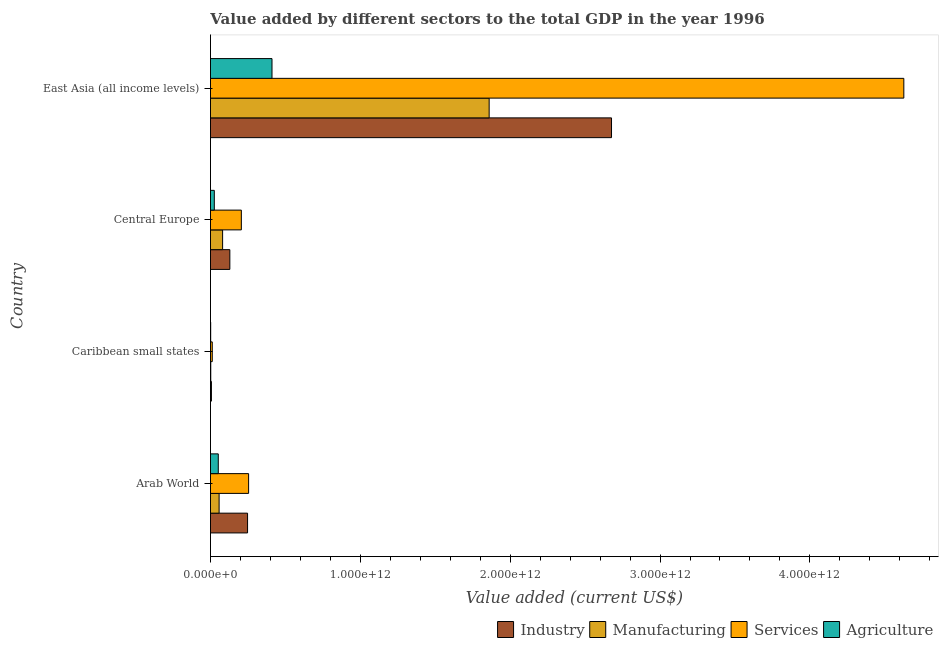How many different coloured bars are there?
Provide a succinct answer. 4. How many groups of bars are there?
Give a very brief answer. 4. Are the number of bars per tick equal to the number of legend labels?
Offer a terse response. Yes. How many bars are there on the 4th tick from the bottom?
Offer a very short reply. 4. What is the label of the 2nd group of bars from the top?
Your response must be concise. Central Europe. In how many cases, is the number of bars for a given country not equal to the number of legend labels?
Provide a succinct answer. 0. What is the value added by agricultural sector in Arab World?
Ensure brevity in your answer.  5.21e+1. Across all countries, what is the maximum value added by manufacturing sector?
Provide a short and direct response. 1.86e+12. Across all countries, what is the minimum value added by industrial sector?
Offer a terse response. 6.28e+09. In which country was the value added by services sector maximum?
Provide a succinct answer. East Asia (all income levels). In which country was the value added by services sector minimum?
Make the answer very short. Caribbean small states. What is the total value added by agricultural sector in the graph?
Ensure brevity in your answer.  4.90e+11. What is the difference between the value added by industrial sector in Arab World and that in East Asia (all income levels)?
Your answer should be very brief. -2.43e+12. What is the difference between the value added by manufacturing sector in Central Europe and the value added by agricultural sector in Caribbean small states?
Provide a succinct answer. 7.96e+1. What is the average value added by services sector per country?
Provide a short and direct response. 1.27e+12. What is the difference between the value added by manufacturing sector and value added by services sector in Caribbean small states?
Make the answer very short. -1.00e+1. In how many countries, is the value added by manufacturing sector greater than 3200000000000 US$?
Your answer should be very brief. 0. What is the ratio of the value added by services sector in Caribbean small states to that in Central Europe?
Provide a short and direct response. 0.06. Is the difference between the value added by manufacturing sector in Arab World and Caribbean small states greater than the difference between the value added by agricultural sector in Arab World and Caribbean small states?
Ensure brevity in your answer.  Yes. What is the difference between the highest and the second highest value added by agricultural sector?
Ensure brevity in your answer.  3.59e+11. What is the difference between the highest and the lowest value added by industrial sector?
Provide a succinct answer. 2.67e+12. In how many countries, is the value added by services sector greater than the average value added by services sector taken over all countries?
Offer a terse response. 1. Is the sum of the value added by manufacturing sector in Arab World and East Asia (all income levels) greater than the maximum value added by agricultural sector across all countries?
Provide a succinct answer. Yes. Is it the case that in every country, the sum of the value added by services sector and value added by industrial sector is greater than the sum of value added by agricultural sector and value added by manufacturing sector?
Make the answer very short. No. What does the 3rd bar from the top in Caribbean small states represents?
Keep it short and to the point. Manufacturing. What does the 2nd bar from the bottom in Caribbean small states represents?
Keep it short and to the point. Manufacturing. How many bars are there?
Your answer should be compact. 16. How many countries are there in the graph?
Your answer should be compact. 4. What is the difference between two consecutive major ticks on the X-axis?
Make the answer very short. 1.00e+12. Does the graph contain grids?
Provide a succinct answer. No. How many legend labels are there?
Offer a terse response. 4. What is the title of the graph?
Provide a succinct answer. Value added by different sectors to the total GDP in the year 1996. Does "Social Protection" appear as one of the legend labels in the graph?
Provide a succinct answer. No. What is the label or title of the X-axis?
Make the answer very short. Value added (current US$). What is the label or title of the Y-axis?
Make the answer very short. Country. What is the Value added (current US$) of Industry in Arab World?
Your answer should be compact. 2.48e+11. What is the Value added (current US$) of Manufacturing in Arab World?
Ensure brevity in your answer.  5.77e+1. What is the Value added (current US$) in Services in Arab World?
Offer a very short reply. 2.54e+11. What is the Value added (current US$) in Agriculture in Arab World?
Offer a very short reply. 5.21e+1. What is the Value added (current US$) of Industry in Caribbean small states?
Your answer should be compact. 6.28e+09. What is the Value added (current US$) of Manufacturing in Caribbean small states?
Give a very brief answer. 1.94e+09. What is the Value added (current US$) of Services in Caribbean small states?
Make the answer very short. 1.20e+1. What is the Value added (current US$) in Agriculture in Caribbean small states?
Ensure brevity in your answer.  1.42e+09. What is the Value added (current US$) of Industry in Central Europe?
Give a very brief answer. 1.29e+11. What is the Value added (current US$) of Manufacturing in Central Europe?
Offer a terse response. 8.10e+1. What is the Value added (current US$) of Services in Central Europe?
Give a very brief answer. 2.06e+11. What is the Value added (current US$) of Agriculture in Central Europe?
Provide a succinct answer. 2.56e+1. What is the Value added (current US$) in Industry in East Asia (all income levels)?
Keep it short and to the point. 2.68e+12. What is the Value added (current US$) in Manufacturing in East Asia (all income levels)?
Your answer should be compact. 1.86e+12. What is the Value added (current US$) in Services in East Asia (all income levels)?
Keep it short and to the point. 4.63e+12. What is the Value added (current US$) in Agriculture in East Asia (all income levels)?
Provide a short and direct response. 4.11e+11. Across all countries, what is the maximum Value added (current US$) in Industry?
Your answer should be compact. 2.68e+12. Across all countries, what is the maximum Value added (current US$) in Manufacturing?
Keep it short and to the point. 1.86e+12. Across all countries, what is the maximum Value added (current US$) in Services?
Provide a succinct answer. 4.63e+12. Across all countries, what is the maximum Value added (current US$) in Agriculture?
Make the answer very short. 4.11e+11. Across all countries, what is the minimum Value added (current US$) of Industry?
Your answer should be very brief. 6.28e+09. Across all countries, what is the minimum Value added (current US$) of Manufacturing?
Offer a terse response. 1.94e+09. Across all countries, what is the minimum Value added (current US$) of Services?
Give a very brief answer. 1.20e+1. Across all countries, what is the minimum Value added (current US$) in Agriculture?
Your response must be concise. 1.42e+09. What is the total Value added (current US$) in Industry in the graph?
Make the answer very short. 3.06e+12. What is the total Value added (current US$) of Manufacturing in the graph?
Provide a succinct answer. 2.00e+12. What is the total Value added (current US$) in Services in the graph?
Provide a short and direct response. 5.10e+12. What is the total Value added (current US$) in Agriculture in the graph?
Provide a succinct answer. 4.90e+11. What is the difference between the Value added (current US$) of Industry in Arab World and that in Caribbean small states?
Ensure brevity in your answer.  2.41e+11. What is the difference between the Value added (current US$) in Manufacturing in Arab World and that in Caribbean small states?
Give a very brief answer. 5.57e+1. What is the difference between the Value added (current US$) of Services in Arab World and that in Caribbean small states?
Keep it short and to the point. 2.43e+11. What is the difference between the Value added (current US$) in Agriculture in Arab World and that in Caribbean small states?
Offer a terse response. 5.07e+1. What is the difference between the Value added (current US$) in Industry in Arab World and that in Central Europe?
Your response must be concise. 1.18e+11. What is the difference between the Value added (current US$) of Manufacturing in Arab World and that in Central Europe?
Make the answer very short. -2.34e+1. What is the difference between the Value added (current US$) in Services in Arab World and that in Central Europe?
Your answer should be very brief. 4.84e+1. What is the difference between the Value added (current US$) of Agriculture in Arab World and that in Central Europe?
Your answer should be very brief. 2.65e+1. What is the difference between the Value added (current US$) of Industry in Arab World and that in East Asia (all income levels)?
Your answer should be very brief. -2.43e+12. What is the difference between the Value added (current US$) in Manufacturing in Arab World and that in East Asia (all income levels)?
Keep it short and to the point. -1.80e+12. What is the difference between the Value added (current US$) in Services in Arab World and that in East Asia (all income levels)?
Give a very brief answer. -4.37e+12. What is the difference between the Value added (current US$) in Agriculture in Arab World and that in East Asia (all income levels)?
Your answer should be very brief. -3.59e+11. What is the difference between the Value added (current US$) of Industry in Caribbean small states and that in Central Europe?
Provide a succinct answer. -1.23e+11. What is the difference between the Value added (current US$) in Manufacturing in Caribbean small states and that in Central Europe?
Make the answer very short. -7.91e+1. What is the difference between the Value added (current US$) of Services in Caribbean small states and that in Central Europe?
Your answer should be very brief. -1.94e+11. What is the difference between the Value added (current US$) in Agriculture in Caribbean small states and that in Central Europe?
Make the answer very short. -2.42e+1. What is the difference between the Value added (current US$) in Industry in Caribbean small states and that in East Asia (all income levels)?
Provide a short and direct response. -2.67e+12. What is the difference between the Value added (current US$) of Manufacturing in Caribbean small states and that in East Asia (all income levels)?
Give a very brief answer. -1.86e+12. What is the difference between the Value added (current US$) of Services in Caribbean small states and that in East Asia (all income levels)?
Offer a very short reply. -4.62e+12. What is the difference between the Value added (current US$) of Agriculture in Caribbean small states and that in East Asia (all income levels)?
Your answer should be very brief. -4.09e+11. What is the difference between the Value added (current US$) in Industry in Central Europe and that in East Asia (all income levels)?
Offer a terse response. -2.55e+12. What is the difference between the Value added (current US$) in Manufacturing in Central Europe and that in East Asia (all income levels)?
Offer a terse response. -1.78e+12. What is the difference between the Value added (current US$) in Services in Central Europe and that in East Asia (all income levels)?
Offer a very short reply. -4.42e+12. What is the difference between the Value added (current US$) in Agriculture in Central Europe and that in East Asia (all income levels)?
Your answer should be very brief. -3.85e+11. What is the difference between the Value added (current US$) of Industry in Arab World and the Value added (current US$) of Manufacturing in Caribbean small states?
Your answer should be very brief. 2.46e+11. What is the difference between the Value added (current US$) in Industry in Arab World and the Value added (current US$) in Services in Caribbean small states?
Your answer should be compact. 2.36e+11. What is the difference between the Value added (current US$) of Industry in Arab World and the Value added (current US$) of Agriculture in Caribbean small states?
Your response must be concise. 2.46e+11. What is the difference between the Value added (current US$) of Manufacturing in Arab World and the Value added (current US$) of Services in Caribbean small states?
Ensure brevity in your answer.  4.57e+1. What is the difference between the Value added (current US$) in Manufacturing in Arab World and the Value added (current US$) in Agriculture in Caribbean small states?
Your answer should be compact. 5.62e+1. What is the difference between the Value added (current US$) of Services in Arab World and the Value added (current US$) of Agriculture in Caribbean small states?
Ensure brevity in your answer.  2.53e+11. What is the difference between the Value added (current US$) of Industry in Arab World and the Value added (current US$) of Manufacturing in Central Europe?
Keep it short and to the point. 1.67e+11. What is the difference between the Value added (current US$) in Industry in Arab World and the Value added (current US$) in Services in Central Europe?
Give a very brief answer. 4.15e+1. What is the difference between the Value added (current US$) in Industry in Arab World and the Value added (current US$) in Agriculture in Central Europe?
Make the answer very short. 2.22e+11. What is the difference between the Value added (current US$) in Manufacturing in Arab World and the Value added (current US$) in Services in Central Europe?
Your response must be concise. -1.48e+11. What is the difference between the Value added (current US$) in Manufacturing in Arab World and the Value added (current US$) in Agriculture in Central Europe?
Your answer should be compact. 3.21e+1. What is the difference between the Value added (current US$) in Services in Arab World and the Value added (current US$) in Agriculture in Central Europe?
Offer a very short reply. 2.29e+11. What is the difference between the Value added (current US$) in Industry in Arab World and the Value added (current US$) in Manufacturing in East Asia (all income levels)?
Your answer should be compact. -1.61e+12. What is the difference between the Value added (current US$) in Industry in Arab World and the Value added (current US$) in Services in East Asia (all income levels)?
Offer a terse response. -4.38e+12. What is the difference between the Value added (current US$) of Industry in Arab World and the Value added (current US$) of Agriculture in East Asia (all income levels)?
Give a very brief answer. -1.63e+11. What is the difference between the Value added (current US$) in Manufacturing in Arab World and the Value added (current US$) in Services in East Asia (all income levels)?
Offer a very short reply. -4.57e+12. What is the difference between the Value added (current US$) of Manufacturing in Arab World and the Value added (current US$) of Agriculture in East Asia (all income levels)?
Offer a very short reply. -3.53e+11. What is the difference between the Value added (current US$) in Services in Arab World and the Value added (current US$) in Agriculture in East Asia (all income levels)?
Provide a succinct answer. -1.56e+11. What is the difference between the Value added (current US$) of Industry in Caribbean small states and the Value added (current US$) of Manufacturing in Central Europe?
Offer a very short reply. -7.47e+1. What is the difference between the Value added (current US$) in Industry in Caribbean small states and the Value added (current US$) in Services in Central Europe?
Provide a short and direct response. -2.00e+11. What is the difference between the Value added (current US$) of Industry in Caribbean small states and the Value added (current US$) of Agriculture in Central Europe?
Offer a very short reply. -1.93e+1. What is the difference between the Value added (current US$) in Manufacturing in Caribbean small states and the Value added (current US$) in Services in Central Europe?
Offer a very short reply. -2.04e+11. What is the difference between the Value added (current US$) in Manufacturing in Caribbean small states and the Value added (current US$) in Agriculture in Central Europe?
Your answer should be very brief. -2.37e+1. What is the difference between the Value added (current US$) of Services in Caribbean small states and the Value added (current US$) of Agriculture in Central Europe?
Give a very brief answer. -1.36e+1. What is the difference between the Value added (current US$) in Industry in Caribbean small states and the Value added (current US$) in Manufacturing in East Asia (all income levels)?
Ensure brevity in your answer.  -1.85e+12. What is the difference between the Value added (current US$) of Industry in Caribbean small states and the Value added (current US$) of Services in East Asia (all income levels)?
Make the answer very short. -4.62e+12. What is the difference between the Value added (current US$) of Industry in Caribbean small states and the Value added (current US$) of Agriculture in East Asia (all income levels)?
Keep it short and to the point. -4.04e+11. What is the difference between the Value added (current US$) in Manufacturing in Caribbean small states and the Value added (current US$) in Services in East Asia (all income levels)?
Your answer should be compact. -4.63e+12. What is the difference between the Value added (current US$) in Manufacturing in Caribbean small states and the Value added (current US$) in Agriculture in East Asia (all income levels)?
Make the answer very short. -4.09e+11. What is the difference between the Value added (current US$) of Services in Caribbean small states and the Value added (current US$) of Agriculture in East Asia (all income levels)?
Your response must be concise. -3.99e+11. What is the difference between the Value added (current US$) of Industry in Central Europe and the Value added (current US$) of Manufacturing in East Asia (all income levels)?
Offer a terse response. -1.73e+12. What is the difference between the Value added (current US$) of Industry in Central Europe and the Value added (current US$) of Services in East Asia (all income levels)?
Give a very brief answer. -4.50e+12. What is the difference between the Value added (current US$) of Industry in Central Europe and the Value added (current US$) of Agriculture in East Asia (all income levels)?
Make the answer very short. -2.81e+11. What is the difference between the Value added (current US$) in Manufacturing in Central Europe and the Value added (current US$) in Services in East Asia (all income levels)?
Provide a succinct answer. -4.55e+12. What is the difference between the Value added (current US$) in Manufacturing in Central Europe and the Value added (current US$) in Agriculture in East Asia (all income levels)?
Your response must be concise. -3.30e+11. What is the difference between the Value added (current US$) in Services in Central Europe and the Value added (current US$) in Agriculture in East Asia (all income levels)?
Your response must be concise. -2.05e+11. What is the average Value added (current US$) in Industry per country?
Keep it short and to the point. 7.65e+11. What is the average Value added (current US$) of Manufacturing per country?
Make the answer very short. 5.00e+11. What is the average Value added (current US$) of Services per country?
Keep it short and to the point. 1.27e+12. What is the average Value added (current US$) of Agriculture per country?
Offer a terse response. 1.22e+11. What is the difference between the Value added (current US$) of Industry and Value added (current US$) of Manufacturing in Arab World?
Make the answer very short. 1.90e+11. What is the difference between the Value added (current US$) in Industry and Value added (current US$) in Services in Arab World?
Provide a succinct answer. -6.91e+09. What is the difference between the Value added (current US$) of Industry and Value added (current US$) of Agriculture in Arab World?
Provide a succinct answer. 1.95e+11. What is the difference between the Value added (current US$) of Manufacturing and Value added (current US$) of Services in Arab World?
Provide a short and direct response. -1.97e+11. What is the difference between the Value added (current US$) of Manufacturing and Value added (current US$) of Agriculture in Arab World?
Your answer should be very brief. 5.57e+09. What is the difference between the Value added (current US$) in Services and Value added (current US$) in Agriculture in Arab World?
Make the answer very short. 2.02e+11. What is the difference between the Value added (current US$) of Industry and Value added (current US$) of Manufacturing in Caribbean small states?
Make the answer very short. 4.35e+09. What is the difference between the Value added (current US$) of Industry and Value added (current US$) of Services in Caribbean small states?
Give a very brief answer. -5.67e+09. What is the difference between the Value added (current US$) in Industry and Value added (current US$) in Agriculture in Caribbean small states?
Your answer should be compact. 4.86e+09. What is the difference between the Value added (current US$) of Manufacturing and Value added (current US$) of Services in Caribbean small states?
Your answer should be compact. -1.00e+1. What is the difference between the Value added (current US$) in Manufacturing and Value added (current US$) in Agriculture in Caribbean small states?
Your response must be concise. 5.15e+08. What is the difference between the Value added (current US$) in Services and Value added (current US$) in Agriculture in Caribbean small states?
Provide a succinct answer. 1.05e+1. What is the difference between the Value added (current US$) of Industry and Value added (current US$) of Manufacturing in Central Europe?
Give a very brief answer. 4.83e+1. What is the difference between the Value added (current US$) of Industry and Value added (current US$) of Services in Central Europe?
Provide a short and direct response. -7.67e+1. What is the difference between the Value added (current US$) of Industry and Value added (current US$) of Agriculture in Central Europe?
Ensure brevity in your answer.  1.04e+11. What is the difference between the Value added (current US$) in Manufacturing and Value added (current US$) in Services in Central Europe?
Your answer should be compact. -1.25e+11. What is the difference between the Value added (current US$) in Manufacturing and Value added (current US$) in Agriculture in Central Europe?
Give a very brief answer. 5.54e+1. What is the difference between the Value added (current US$) in Services and Value added (current US$) in Agriculture in Central Europe?
Provide a succinct answer. 1.80e+11. What is the difference between the Value added (current US$) of Industry and Value added (current US$) of Manufacturing in East Asia (all income levels)?
Your response must be concise. 8.17e+11. What is the difference between the Value added (current US$) in Industry and Value added (current US$) in Services in East Asia (all income levels)?
Offer a very short reply. -1.95e+12. What is the difference between the Value added (current US$) in Industry and Value added (current US$) in Agriculture in East Asia (all income levels)?
Give a very brief answer. 2.27e+12. What is the difference between the Value added (current US$) of Manufacturing and Value added (current US$) of Services in East Asia (all income levels)?
Your answer should be compact. -2.77e+12. What is the difference between the Value added (current US$) in Manufacturing and Value added (current US$) in Agriculture in East Asia (all income levels)?
Provide a succinct answer. 1.45e+12. What is the difference between the Value added (current US$) in Services and Value added (current US$) in Agriculture in East Asia (all income levels)?
Offer a very short reply. 4.22e+12. What is the ratio of the Value added (current US$) in Industry in Arab World to that in Caribbean small states?
Offer a very short reply. 39.4. What is the ratio of the Value added (current US$) in Manufacturing in Arab World to that in Caribbean small states?
Your response must be concise. 29.76. What is the ratio of the Value added (current US$) of Services in Arab World to that in Caribbean small states?
Keep it short and to the point. 21.29. What is the ratio of the Value added (current US$) of Agriculture in Arab World to that in Caribbean small states?
Offer a terse response. 36.6. What is the ratio of the Value added (current US$) of Industry in Arab World to that in Central Europe?
Offer a terse response. 1.91. What is the ratio of the Value added (current US$) in Manufacturing in Arab World to that in Central Europe?
Make the answer very short. 0.71. What is the ratio of the Value added (current US$) of Services in Arab World to that in Central Europe?
Ensure brevity in your answer.  1.24. What is the ratio of the Value added (current US$) of Agriculture in Arab World to that in Central Europe?
Offer a terse response. 2.04. What is the ratio of the Value added (current US$) in Industry in Arab World to that in East Asia (all income levels)?
Your answer should be compact. 0.09. What is the ratio of the Value added (current US$) in Manufacturing in Arab World to that in East Asia (all income levels)?
Provide a short and direct response. 0.03. What is the ratio of the Value added (current US$) of Services in Arab World to that in East Asia (all income levels)?
Your answer should be very brief. 0.06. What is the ratio of the Value added (current US$) of Agriculture in Arab World to that in East Asia (all income levels)?
Your response must be concise. 0.13. What is the ratio of the Value added (current US$) in Industry in Caribbean small states to that in Central Europe?
Your answer should be compact. 0.05. What is the ratio of the Value added (current US$) in Manufacturing in Caribbean small states to that in Central Europe?
Provide a short and direct response. 0.02. What is the ratio of the Value added (current US$) of Services in Caribbean small states to that in Central Europe?
Your answer should be compact. 0.06. What is the ratio of the Value added (current US$) of Agriculture in Caribbean small states to that in Central Europe?
Ensure brevity in your answer.  0.06. What is the ratio of the Value added (current US$) in Industry in Caribbean small states to that in East Asia (all income levels)?
Provide a succinct answer. 0. What is the ratio of the Value added (current US$) of Manufacturing in Caribbean small states to that in East Asia (all income levels)?
Your response must be concise. 0. What is the ratio of the Value added (current US$) of Services in Caribbean small states to that in East Asia (all income levels)?
Your answer should be compact. 0. What is the ratio of the Value added (current US$) of Agriculture in Caribbean small states to that in East Asia (all income levels)?
Your answer should be compact. 0. What is the ratio of the Value added (current US$) of Industry in Central Europe to that in East Asia (all income levels)?
Offer a terse response. 0.05. What is the ratio of the Value added (current US$) of Manufacturing in Central Europe to that in East Asia (all income levels)?
Your answer should be compact. 0.04. What is the ratio of the Value added (current US$) of Services in Central Europe to that in East Asia (all income levels)?
Offer a terse response. 0.04. What is the ratio of the Value added (current US$) of Agriculture in Central Europe to that in East Asia (all income levels)?
Ensure brevity in your answer.  0.06. What is the difference between the highest and the second highest Value added (current US$) in Industry?
Make the answer very short. 2.43e+12. What is the difference between the highest and the second highest Value added (current US$) in Manufacturing?
Your answer should be very brief. 1.78e+12. What is the difference between the highest and the second highest Value added (current US$) of Services?
Offer a very short reply. 4.37e+12. What is the difference between the highest and the second highest Value added (current US$) of Agriculture?
Offer a very short reply. 3.59e+11. What is the difference between the highest and the lowest Value added (current US$) in Industry?
Provide a short and direct response. 2.67e+12. What is the difference between the highest and the lowest Value added (current US$) of Manufacturing?
Offer a very short reply. 1.86e+12. What is the difference between the highest and the lowest Value added (current US$) of Services?
Offer a terse response. 4.62e+12. What is the difference between the highest and the lowest Value added (current US$) in Agriculture?
Provide a short and direct response. 4.09e+11. 